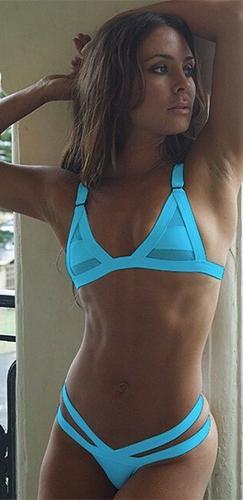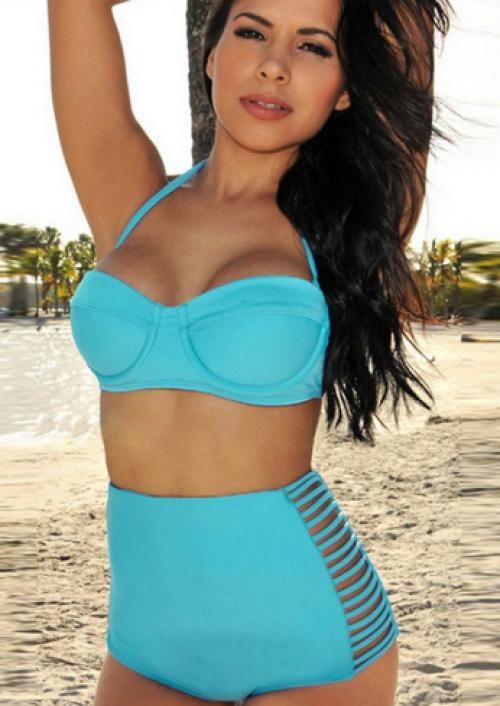The first image is the image on the left, the second image is the image on the right. For the images displayed, is the sentence "Models wear the same color bikinis in left and right images." factually correct? Answer yes or no. Yes. The first image is the image on the left, the second image is the image on the right. Given the left and right images, does the statement "In one of the images, a woman is wearing a white bikini" hold true? Answer yes or no. No. 